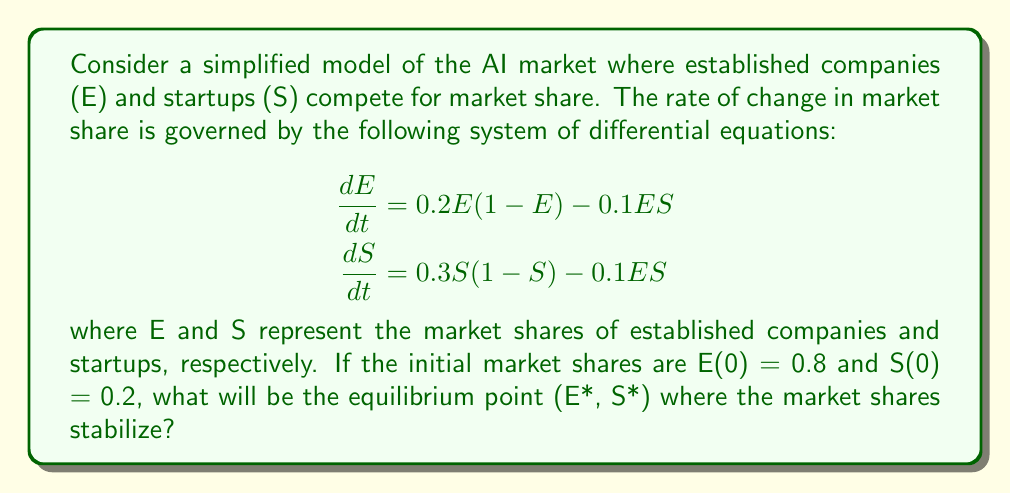Solve this math problem. To find the equilibrium point, we need to set both equations equal to zero and solve for E and S:

1) Set $\frac{dE}{dt} = 0$ and $\frac{dS}{dt} = 0$:

   $$\begin{aligned}
   0 &= 0.2E(1-E) - 0.1ES \\
   0 &= 0.3S(1-S) - 0.1ES
   \end{aligned}$$

2) From the first equation:
   
   $$\begin{aligned}
   0.2E(1-E) &= 0.1ES \\
   0.2 - 0.2E &= 0.1S \\
   2 - 2E &= S
   \end{aligned}$$

3) Substitute this into the second equation:

   $$\begin{aligned}
   0 &= 0.3(2-2E)(1-(2-2E)) - 0.1E(2-2E) \\
   0 &= 0.3(2-2E)(2E-1) - 0.2E(1-E)
   \end{aligned}$$

4) Expand and simplify:

   $$\begin{aligned}
   0 &= 1.2E - 0.6 - 1.2E^2 + 0.6E - 0.2E + 0.2E^2 \\
   0 &= -E^2 + 1.6E - 0.6 \\
   E^2 - 1.6E + 0.6 &= 0
   \end{aligned}$$

5) Solve this quadratic equation:

   $$E = \frac{1.6 \pm \sqrt{1.6^2 - 4(1)(0.6)}}{2(1)} = \frac{1.6 \pm \sqrt{1.36}}{2} = \frac{1.6 \pm 1.17}{2}$$

   This gives us two solutions: $E \approx 1.38$ or $E \approx 0.22$

6) Since E represents a market share, it must be between 0 and 1. Therefore, E* ≈ 0.22

7) Calculate S* using the equation from step 2:

   $$S* = 2 - 2E* \approx 2 - 2(0.22) = 1.56$$

8) However, S* must also be between 0 and 1. The correct equilibrium point is therefore:

   E* ≈ 0.22 and S* ≈ 0.78

This equilibrium point represents a stable market share distribution where established companies hold about 22% of the market, and startups hold about 78%.
Answer: (0.22, 0.78) 